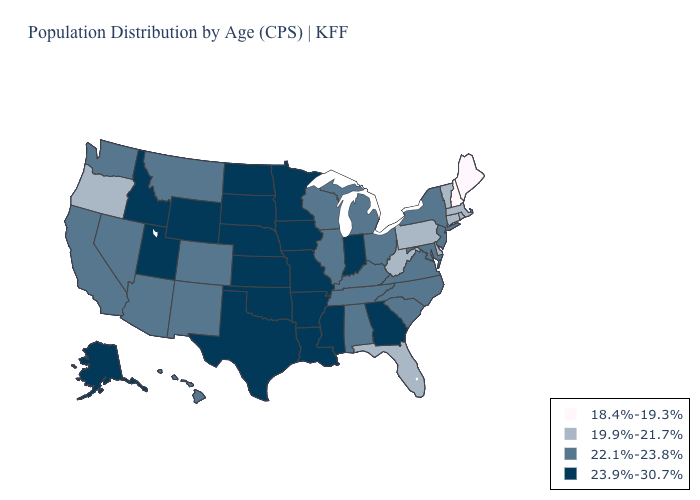Name the states that have a value in the range 22.1%-23.8%?
Write a very short answer. Alabama, Arizona, California, Colorado, Hawaii, Illinois, Kentucky, Maryland, Michigan, Montana, Nevada, New Jersey, New Mexico, New York, North Carolina, Ohio, South Carolina, Tennessee, Virginia, Washington, Wisconsin. What is the value of Utah?
Write a very short answer. 23.9%-30.7%. What is the value of Oklahoma?
Quick response, please. 23.9%-30.7%. What is the highest value in the Northeast ?
Concise answer only. 22.1%-23.8%. Does Virginia have the lowest value in the South?
Write a very short answer. No. Name the states that have a value in the range 19.9%-21.7%?
Give a very brief answer. Connecticut, Delaware, Florida, Massachusetts, Oregon, Pennsylvania, Rhode Island, Vermont, West Virginia. What is the lowest value in states that border North Dakota?
Answer briefly. 22.1%-23.8%. Name the states that have a value in the range 18.4%-19.3%?
Be succinct. Maine, New Hampshire. Which states have the highest value in the USA?
Answer briefly. Alaska, Arkansas, Georgia, Idaho, Indiana, Iowa, Kansas, Louisiana, Minnesota, Mississippi, Missouri, Nebraska, North Dakota, Oklahoma, South Dakota, Texas, Utah, Wyoming. What is the value of Oklahoma?
Quick response, please. 23.9%-30.7%. Among the states that border Florida , does Georgia have the highest value?
Be succinct. Yes. Which states have the lowest value in the MidWest?
Be succinct. Illinois, Michigan, Ohio, Wisconsin. Name the states that have a value in the range 23.9%-30.7%?
Write a very short answer. Alaska, Arkansas, Georgia, Idaho, Indiana, Iowa, Kansas, Louisiana, Minnesota, Mississippi, Missouri, Nebraska, North Dakota, Oklahoma, South Dakota, Texas, Utah, Wyoming. What is the highest value in states that border North Dakota?
Give a very brief answer. 23.9%-30.7%. Among the states that border California , which have the lowest value?
Short answer required. Oregon. 